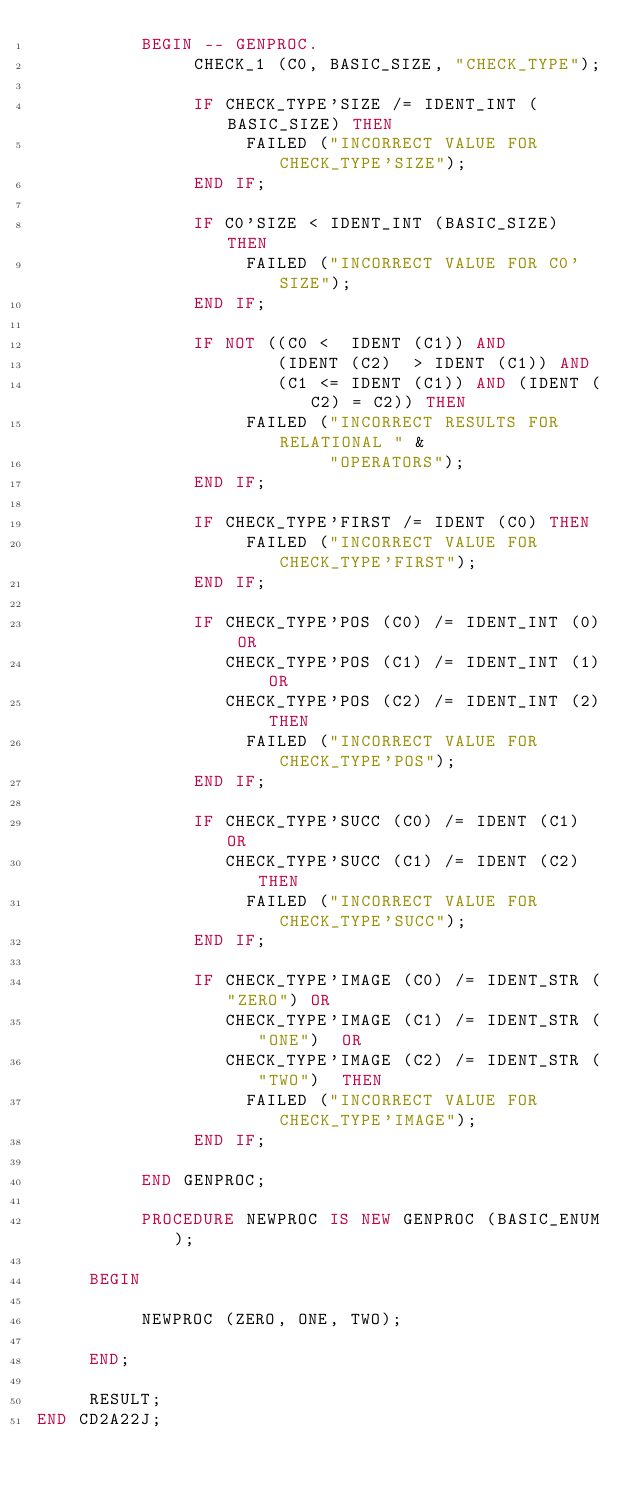Convert code to text. <code><loc_0><loc_0><loc_500><loc_500><_Ada_>          BEGIN -- GENPROC.
               CHECK_1 (C0, BASIC_SIZE, "CHECK_TYPE");

               IF CHECK_TYPE'SIZE /= IDENT_INT (BASIC_SIZE) THEN
                    FAILED ("INCORRECT VALUE FOR CHECK_TYPE'SIZE");
               END IF;

               IF C0'SIZE < IDENT_INT (BASIC_SIZE) THEN
                    FAILED ("INCORRECT VALUE FOR C0'SIZE");
               END IF;

               IF NOT ((C0 <  IDENT (C1)) AND
                       (IDENT (C2)  > IDENT (C1)) AND
                       (C1 <= IDENT (C1)) AND (IDENT (C2) = C2)) THEN
                    FAILED ("INCORRECT RESULTS FOR RELATIONAL " &
                            "OPERATORS");
               END IF;

               IF CHECK_TYPE'FIRST /= IDENT (C0) THEN
                    FAILED ("INCORRECT VALUE FOR CHECK_TYPE'FIRST");
               END IF;

               IF CHECK_TYPE'POS (C0) /= IDENT_INT (0) OR
                  CHECK_TYPE'POS (C1) /= IDENT_INT (1) OR
                  CHECK_TYPE'POS (C2) /= IDENT_INT (2) THEN
                    FAILED ("INCORRECT VALUE FOR CHECK_TYPE'POS");
               END IF;

               IF CHECK_TYPE'SUCC (C0) /= IDENT (C1) OR
                  CHECK_TYPE'SUCC (C1) /= IDENT (C2) THEN
                    FAILED ("INCORRECT VALUE FOR CHECK_TYPE'SUCC");
               END IF;

               IF CHECK_TYPE'IMAGE (C0) /= IDENT_STR ("ZERO") OR
                  CHECK_TYPE'IMAGE (C1) /= IDENT_STR ("ONE")  OR
                  CHECK_TYPE'IMAGE (C2) /= IDENT_STR ("TWO")  THEN
                    FAILED ("INCORRECT VALUE FOR CHECK_TYPE'IMAGE");
               END IF;

          END GENPROC;

          PROCEDURE NEWPROC IS NEW GENPROC (BASIC_ENUM);

     BEGIN

          NEWPROC (ZERO, ONE, TWO);

     END;

     RESULT;
END CD2A22J;
</code> 